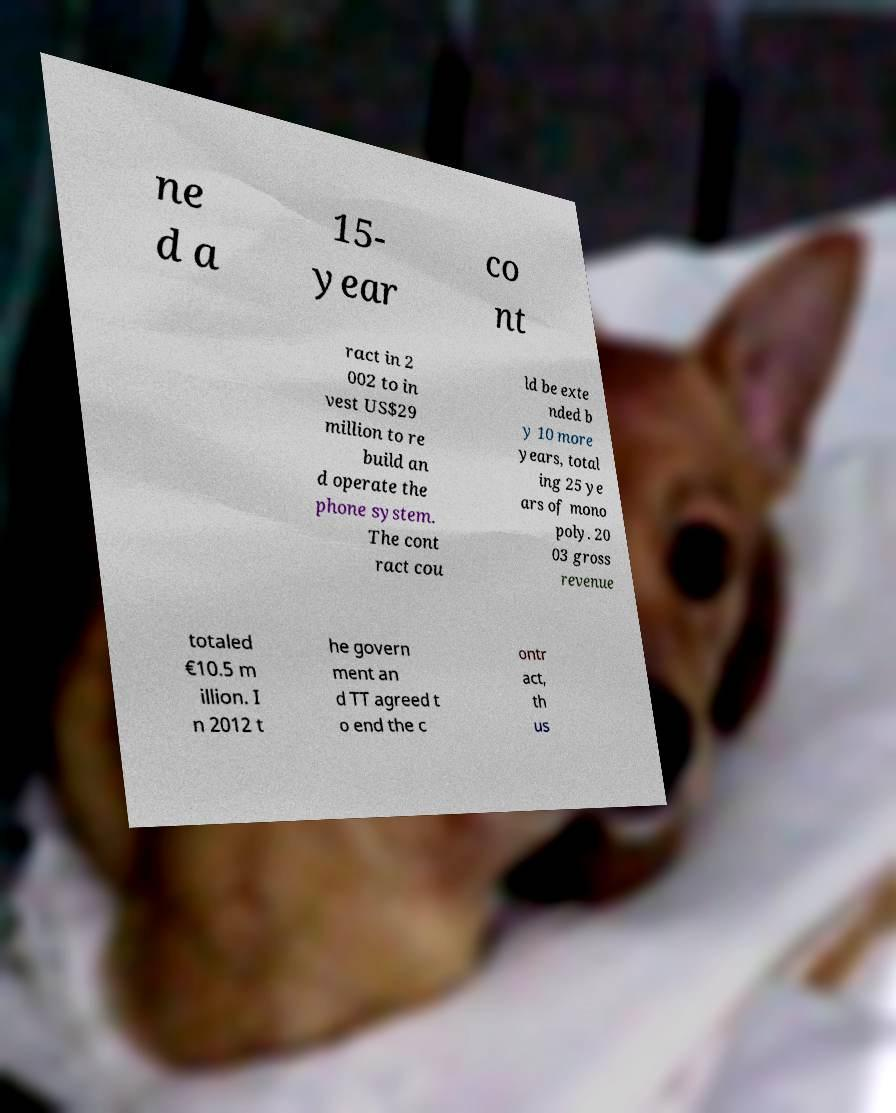Please read and relay the text visible in this image. What does it say? ne d a 15- year co nt ract in 2 002 to in vest US$29 million to re build an d operate the phone system. The cont ract cou ld be exte nded b y 10 more years, total ing 25 ye ars of mono poly. 20 03 gross revenue totaled €10.5 m illion. I n 2012 t he govern ment an d TT agreed t o end the c ontr act, th us 